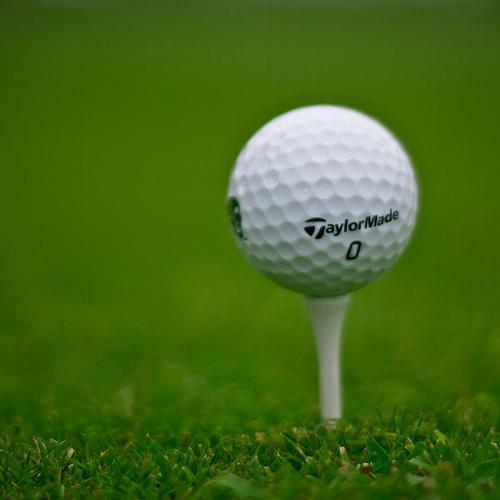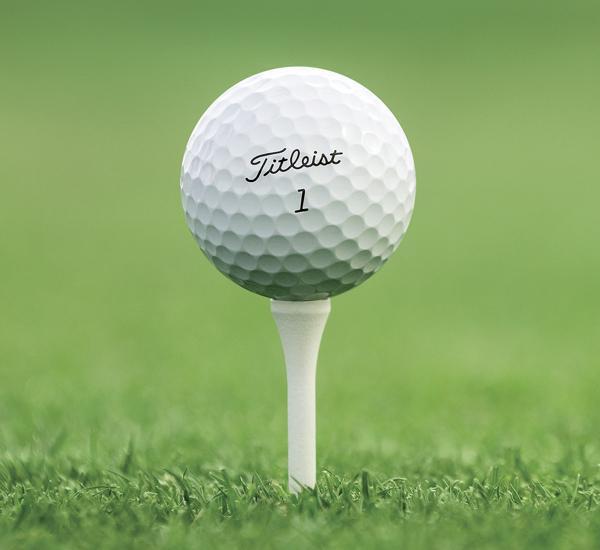The first image is the image on the left, the second image is the image on the right. Considering the images on both sides, is "There is not less than one golf ball resting on a tee" valid? Answer yes or no. Yes. 